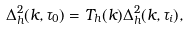Convert formula to latex. <formula><loc_0><loc_0><loc_500><loc_500>\Delta _ { h } ^ { 2 } ( k , \tau _ { 0 } ) = T _ { h } ( k ) \Delta _ { h } ^ { 2 } ( k , \tau _ { i } ) ,</formula> 